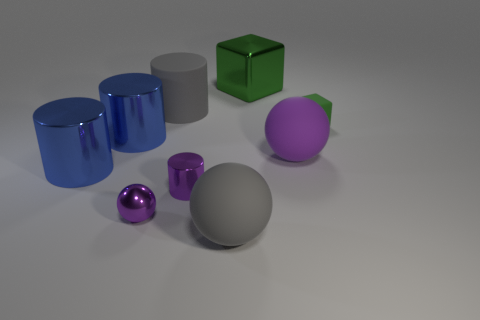Subtract all brown cylinders. Subtract all cyan balls. How many cylinders are left? 4 Add 1 big metallic blocks. How many objects exist? 10 Subtract all spheres. How many objects are left? 6 Add 2 purple shiny spheres. How many purple shiny spheres are left? 3 Add 3 tiny rubber blocks. How many tiny rubber blocks exist? 4 Subtract 0 cyan balls. How many objects are left? 9 Subtract all tiny green cubes. Subtract all cubes. How many objects are left? 6 